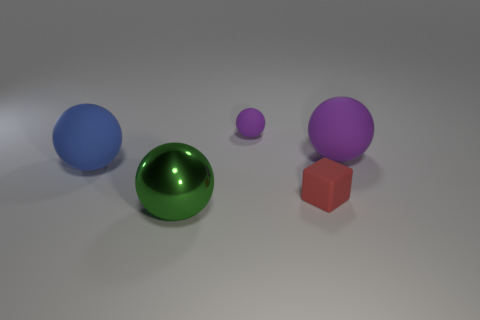The purple thing that is the same size as the block is what shape? The purple object that shares its size with the block is spherical in shape. 